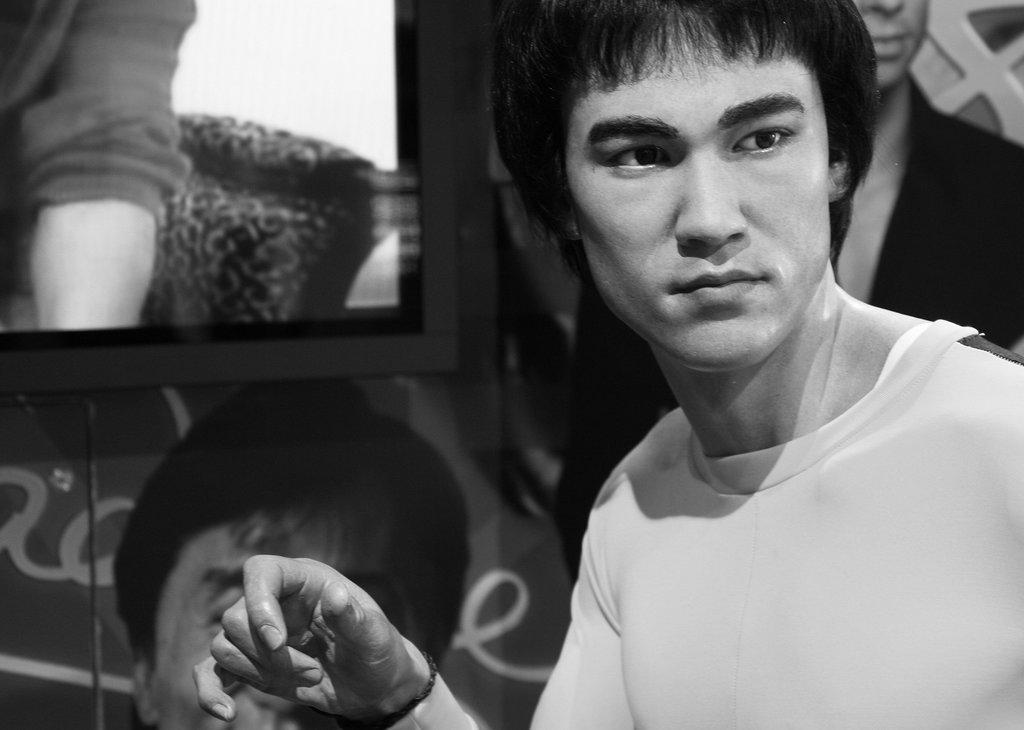How many people are present in the image? There are two people in the image. What can be seen in the image besides the people? There is a screen in the image. What is the color scheme of the image? The photography is in black and white. What type of brain is visible on the screen in the image? There is no brain visible on the screen in the image. 